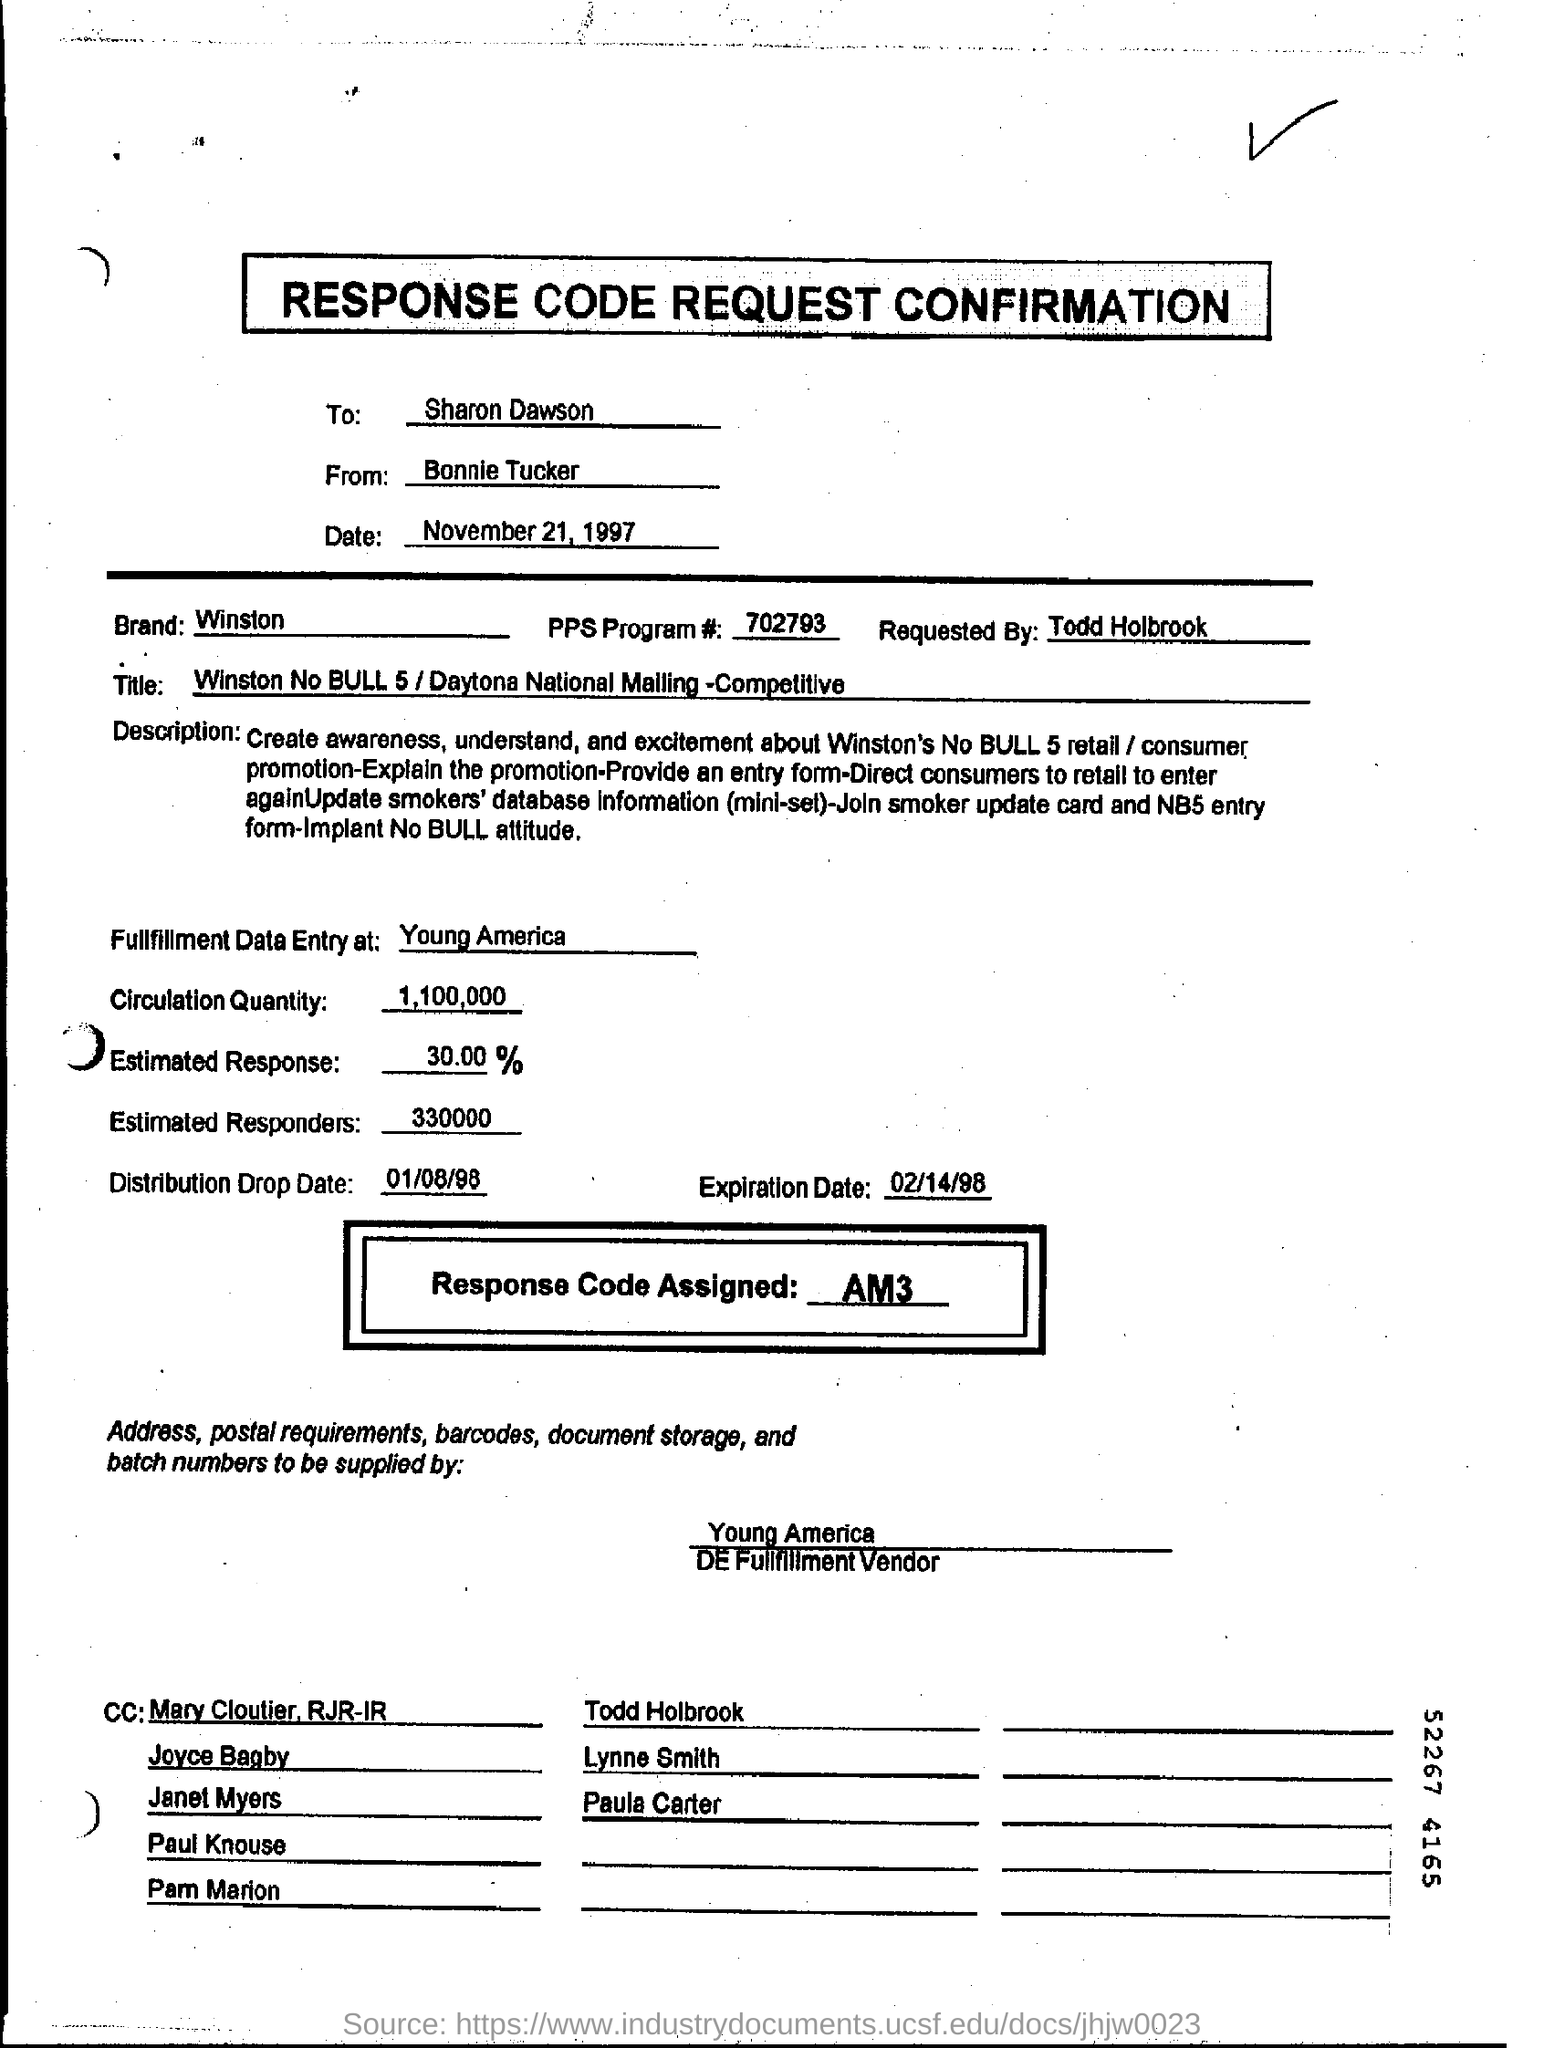Draw attention to some important aspects in this diagram. The date of the request is November 21, 1997. The brand mentioned is Winston. The sender of this request is Bonnie Tucker. The request is directed to Sharon Dawson. 